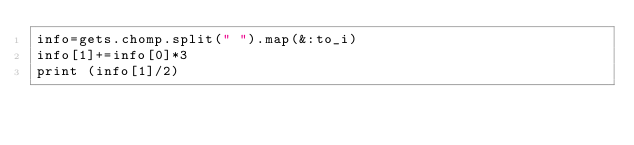<code> <loc_0><loc_0><loc_500><loc_500><_Ruby_>info=gets.chomp.split(" ").map(&:to_i)
info[1]+=info[0]*3
print (info[1]/2)</code> 